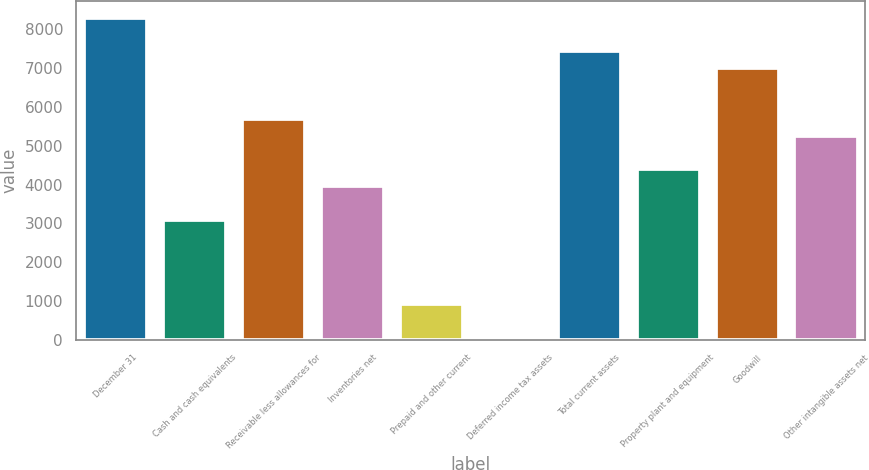<chart> <loc_0><loc_0><loc_500><loc_500><bar_chart><fcel>December 31<fcel>Cash and cash equivalents<fcel>Receivable less allowances for<fcel>Inventories net<fcel>Prepaid and other current<fcel>Deferred income tax assets<fcel>Total current assets<fcel>Property plant and equipment<fcel>Goodwill<fcel>Other intangible assets net<nl><fcel>8306.2<fcel>3088.6<fcel>5697.4<fcel>3958.2<fcel>914.6<fcel>45<fcel>7436.6<fcel>4393<fcel>7001.8<fcel>5262.6<nl></chart> 